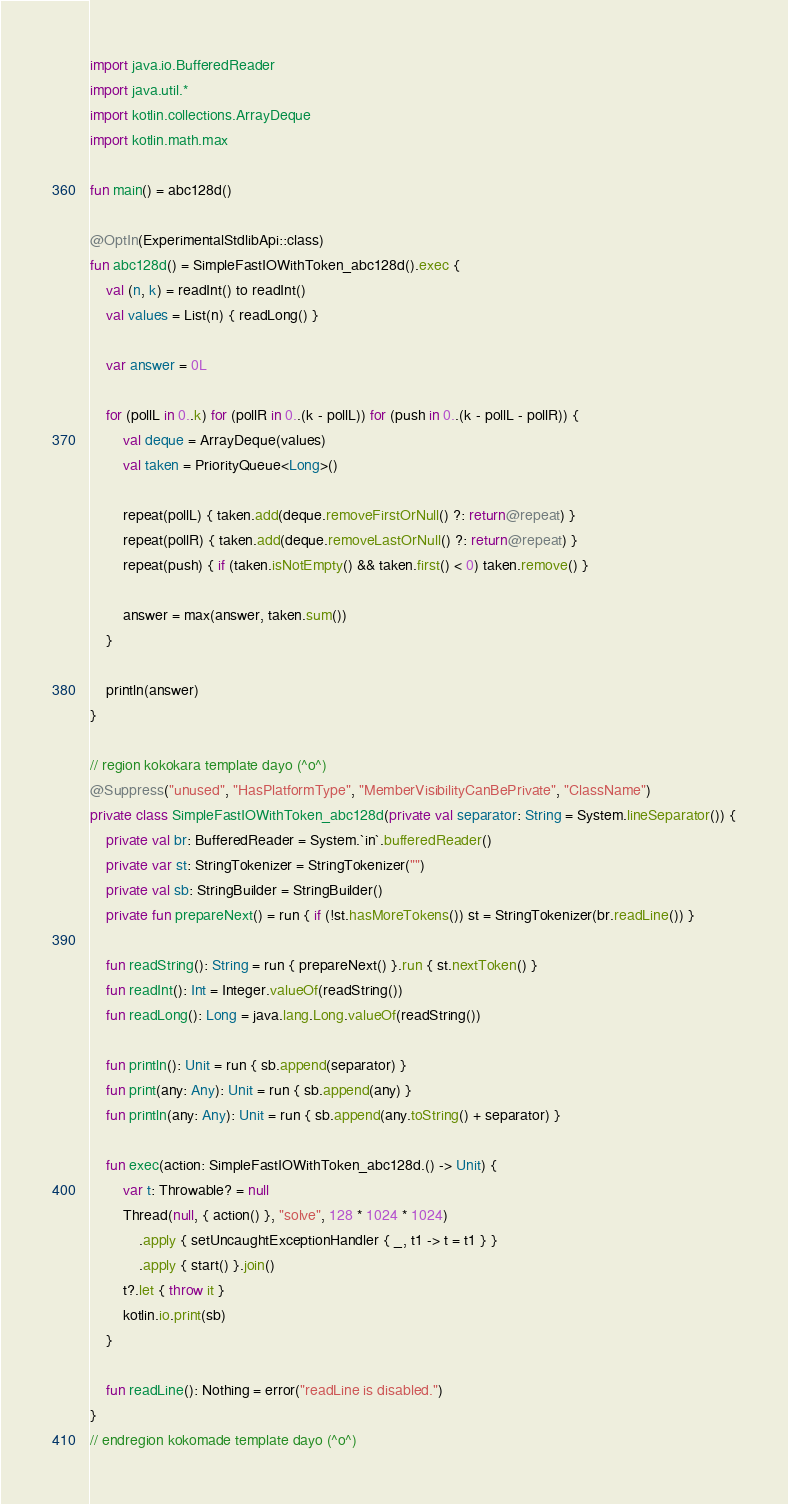<code> <loc_0><loc_0><loc_500><loc_500><_Kotlin_>import java.io.BufferedReader
import java.util.*
import kotlin.collections.ArrayDeque
import kotlin.math.max

fun main() = abc128d()

@OptIn(ExperimentalStdlibApi::class)
fun abc128d() = SimpleFastIOWithToken_abc128d().exec {
    val (n, k) = readInt() to readInt()
    val values = List(n) { readLong() }

    var answer = 0L

    for (pollL in 0..k) for (pollR in 0..(k - pollL)) for (push in 0..(k - pollL - pollR)) {
        val deque = ArrayDeque(values)
        val taken = PriorityQueue<Long>()

        repeat(pollL) { taken.add(deque.removeFirstOrNull() ?: return@repeat) }
        repeat(pollR) { taken.add(deque.removeLastOrNull() ?: return@repeat) }
        repeat(push) { if (taken.isNotEmpty() && taken.first() < 0) taken.remove() }

        answer = max(answer, taken.sum())
    }

    println(answer)
}

// region kokokara template dayo (^o^)
@Suppress("unused", "HasPlatformType", "MemberVisibilityCanBePrivate", "ClassName")
private class SimpleFastIOWithToken_abc128d(private val separator: String = System.lineSeparator()) {
    private val br: BufferedReader = System.`in`.bufferedReader()
    private var st: StringTokenizer = StringTokenizer("")
    private val sb: StringBuilder = StringBuilder()
    private fun prepareNext() = run { if (!st.hasMoreTokens()) st = StringTokenizer(br.readLine()) }

    fun readString(): String = run { prepareNext() }.run { st.nextToken() }
    fun readInt(): Int = Integer.valueOf(readString())
    fun readLong(): Long = java.lang.Long.valueOf(readString())

    fun println(): Unit = run { sb.append(separator) }
    fun print(any: Any): Unit = run { sb.append(any) }
    fun println(any: Any): Unit = run { sb.append(any.toString() + separator) }

    fun exec(action: SimpleFastIOWithToken_abc128d.() -> Unit) {
        var t: Throwable? = null
        Thread(null, { action() }, "solve", 128 * 1024 * 1024)
            .apply { setUncaughtExceptionHandler { _, t1 -> t = t1 } }
            .apply { start() }.join()
        t?.let { throw it }
        kotlin.io.print(sb)
    }

    fun readLine(): Nothing = error("readLine is disabled.")
}
// endregion kokomade template dayo (^o^)
</code> 